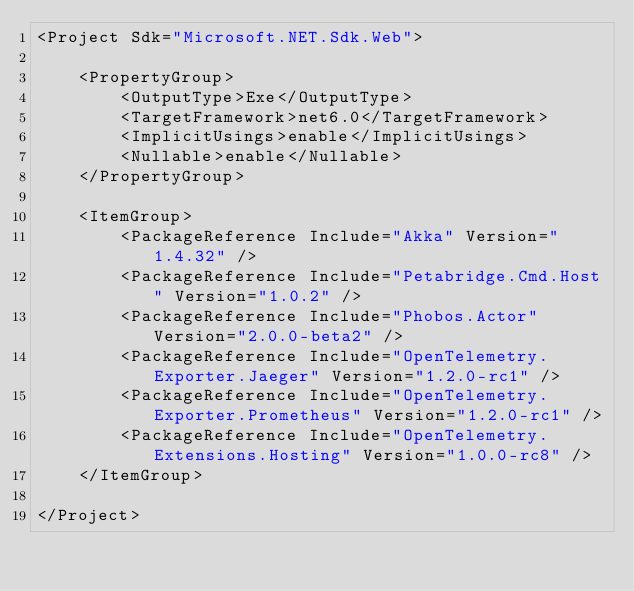Convert code to text. <code><loc_0><loc_0><loc_500><loc_500><_XML_><Project Sdk="Microsoft.NET.Sdk.Web">

    <PropertyGroup>
        <OutputType>Exe</OutputType>
        <TargetFramework>net6.0</TargetFramework>
        <ImplicitUsings>enable</ImplicitUsings>
        <Nullable>enable</Nullable>
    </PropertyGroup>

    <ItemGroup>
        <PackageReference Include="Akka" Version="1.4.32" />
        <PackageReference Include="Petabridge.Cmd.Host" Version="1.0.2" />
        <PackageReference Include="Phobos.Actor" Version="2.0.0-beta2" />
        <PackageReference Include="OpenTelemetry.Exporter.Jaeger" Version="1.2.0-rc1" />
        <PackageReference Include="OpenTelemetry.Exporter.Prometheus" Version="1.2.0-rc1" />
        <PackageReference Include="OpenTelemetry.Extensions.Hosting" Version="1.0.0-rc8" />
    </ItemGroup>

</Project>
</code> 